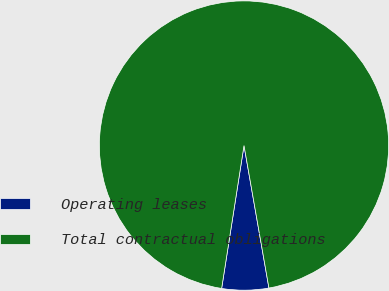<chart> <loc_0><loc_0><loc_500><loc_500><pie_chart><fcel>Operating leases<fcel>Total contractual obligations<nl><fcel>5.23%<fcel>94.77%<nl></chart> 